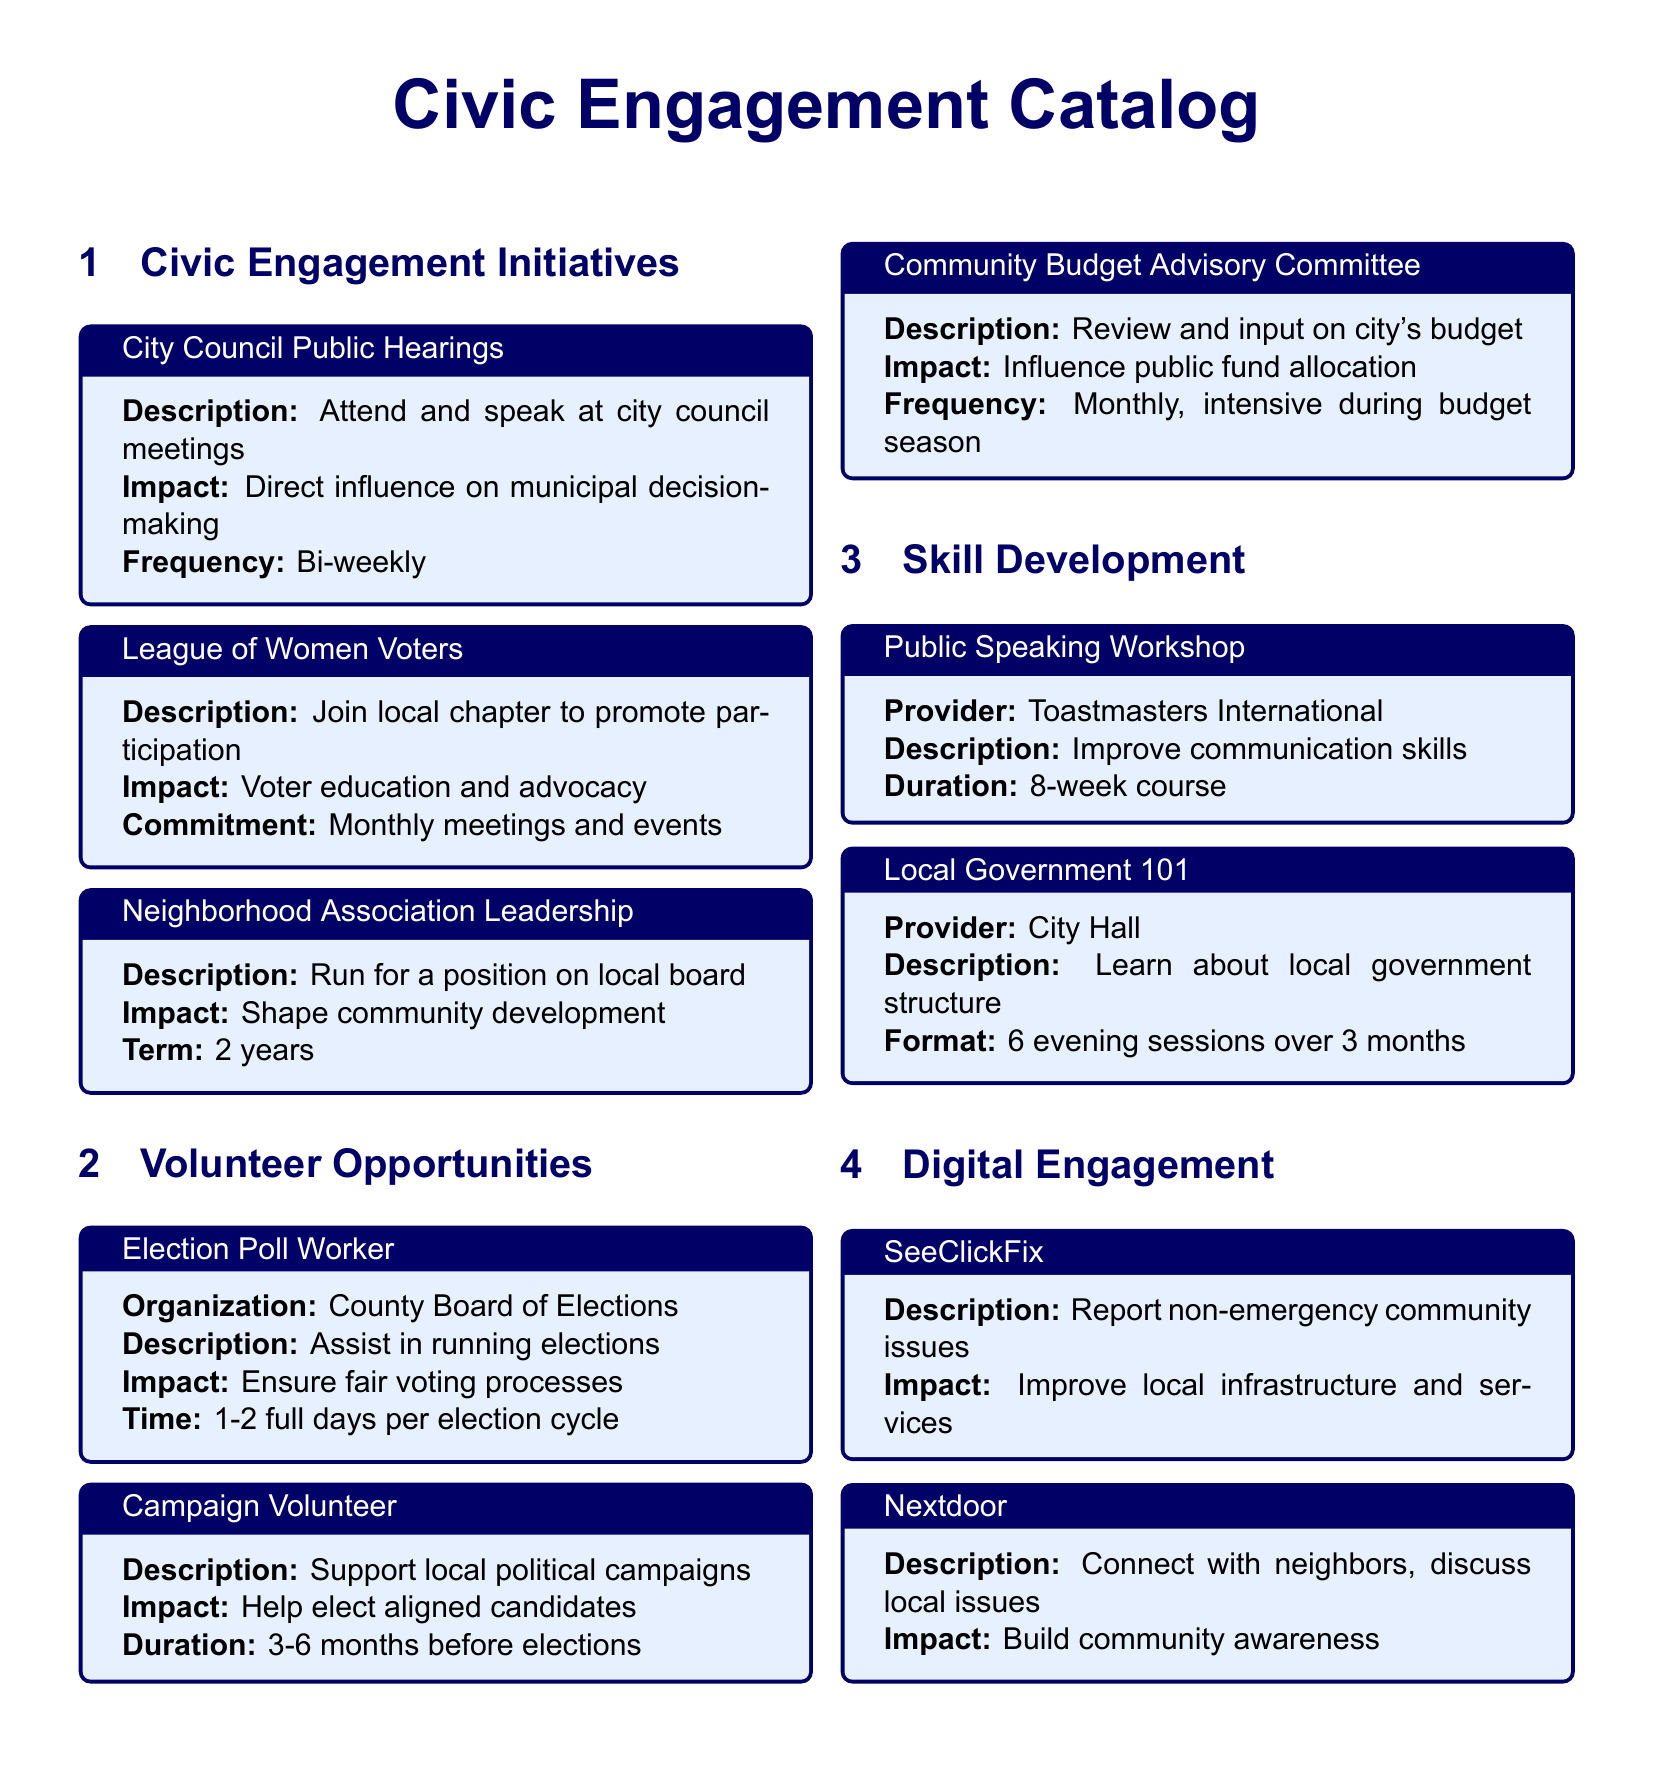What is the frequency of City Council Public Hearings? The frequency is mentioned in the document under "City Council Public Hearings," which states it is bi-weekly.
Answer: Bi-weekly How long does the Neighborhood Association Leadership term last? The term duration is specified in the document for the "Neighborhood Association Leadership" initiative, which mentions it is 2 years.
Answer: 2 years What organization provides the Public Speaking Workshop? The document specifies that the provider for the "Public Speaking Workshop" is Toastmasters International.
Answer: Toastmasters International What is the impact of volunteering as an Election Poll Worker? The impact of serving as an Election Poll Worker noted in the document is to ensure fair voting processes.
Answer: Ensure fair voting processes How often does the Community Budget Advisory Committee meet? The frequency of meetings is stated in the document, indicating that it meets monthly and becomes intensive during budget season.
Answer: Monthly, intensive during budget season What type of issues can be reported through SeeClickFix? The document specifies that non-emergency community issues can be reported through SeeClickFix.
Answer: Non-emergency community issues What is the duration of the Local Government 101 sessions? The duration of the "Local Government 101" sessions is detailed in the document, mentioning it consists of 6 evening sessions over 3 months.
Answer: 6 evening sessions over 3 months What is one of the impacts of joining the League of Women Voters? The document outlines that one of the impacts of joining the League of Women Voters is voter education and advocacy.
Answer: Voter education and advocacy 